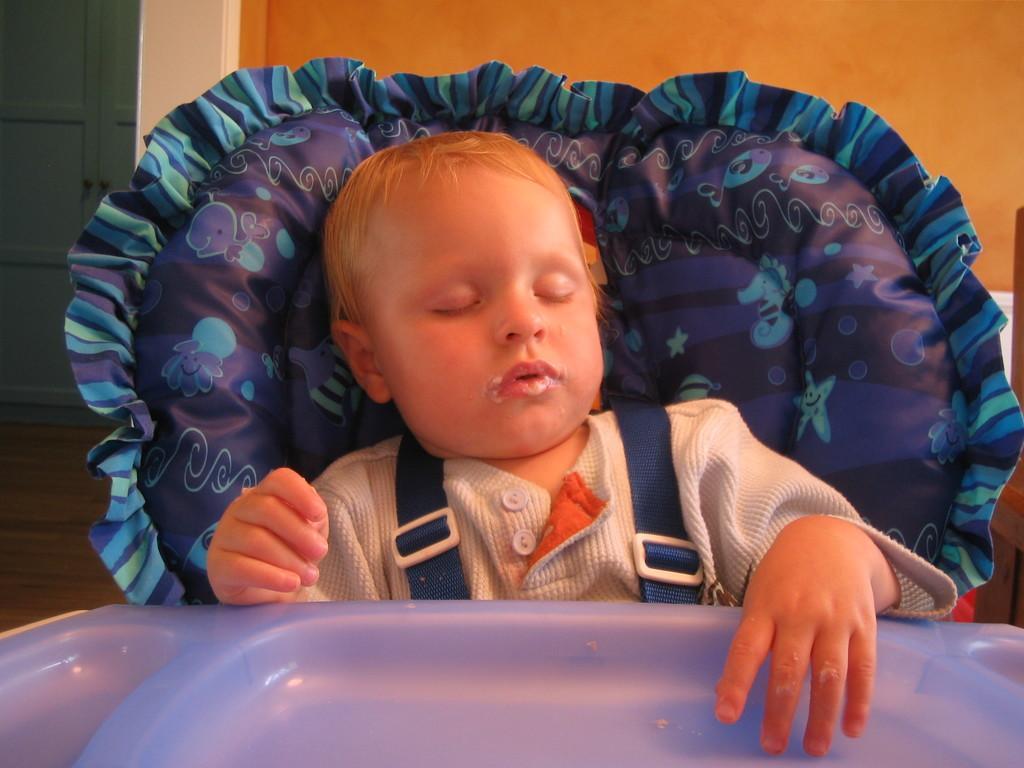Can you describe this image briefly? In this image we can see a kid sleeping, behind with him there is a cushion, in front of him there is a plate, also we can see the wall, and a closet. 